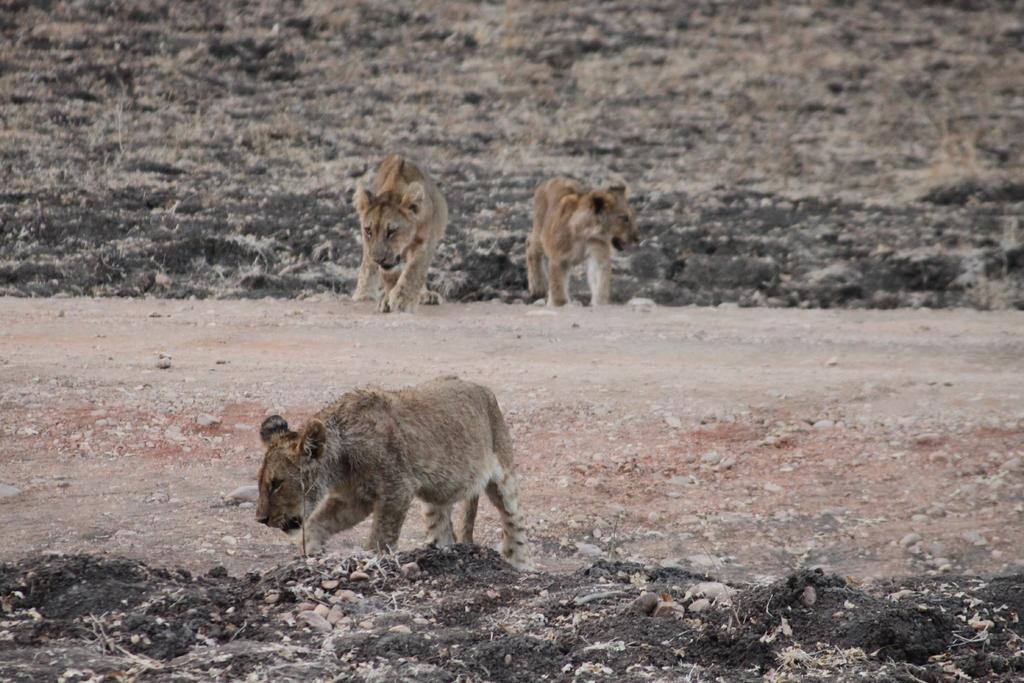How would you summarize this image in a sentence or two? Here we can see three lions on the ground. 